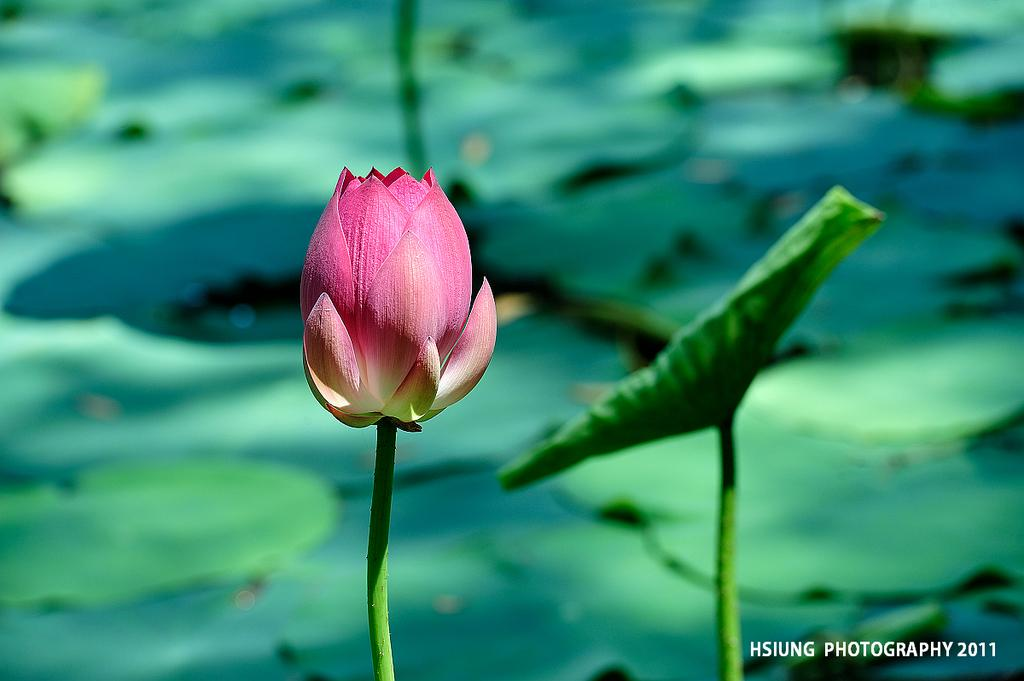What type of flower is in the image? There is a pink color flower in the image. What other plant part can be seen in the image? There is a leaf in the image. How would you describe the background of the image? The background of the image is blurred. Is there any additional information or marking on the image? Yes, there is a watermark in the image. What type of crate is being used for the protest in the image? There is no crate or protest present in the image; it features a pink flower and a leaf with a blurred background and a watermark. 